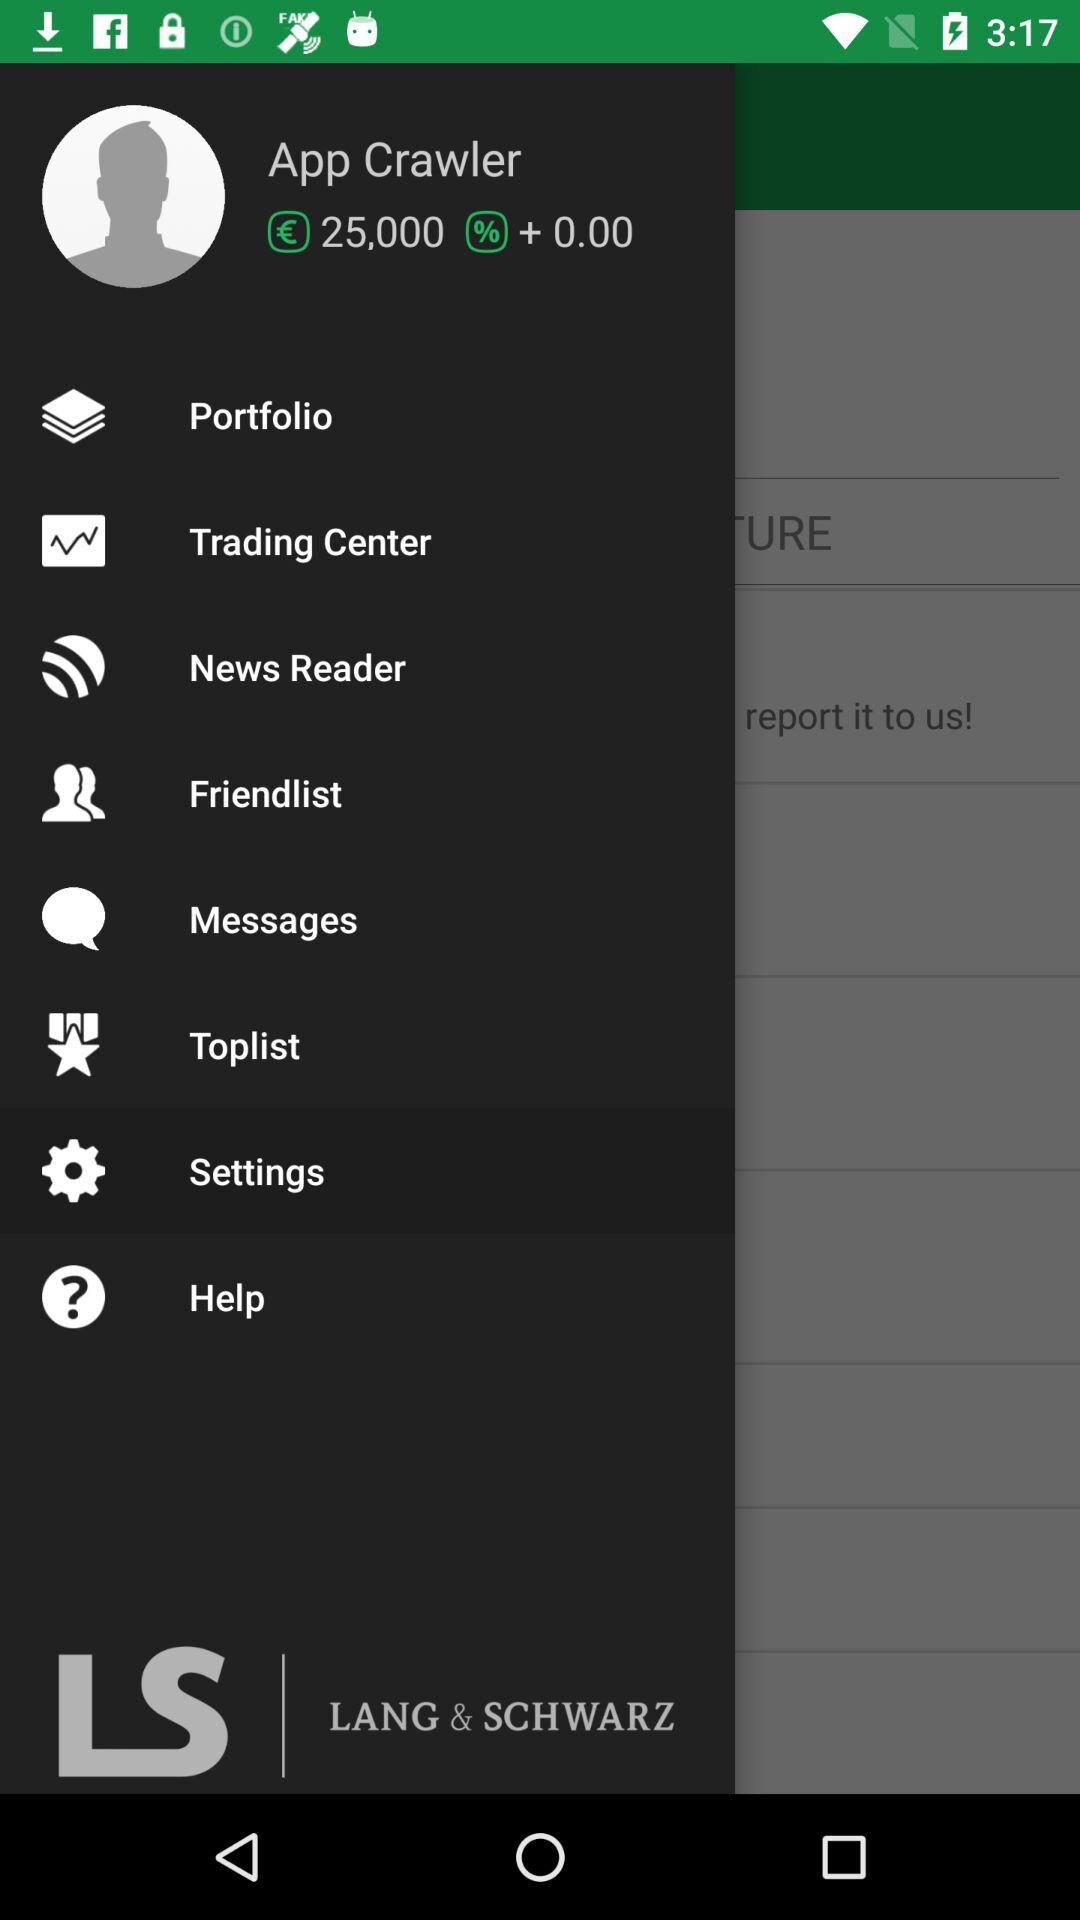How much money do I have in my wallet? You have 25,000 euros in your wallet. 